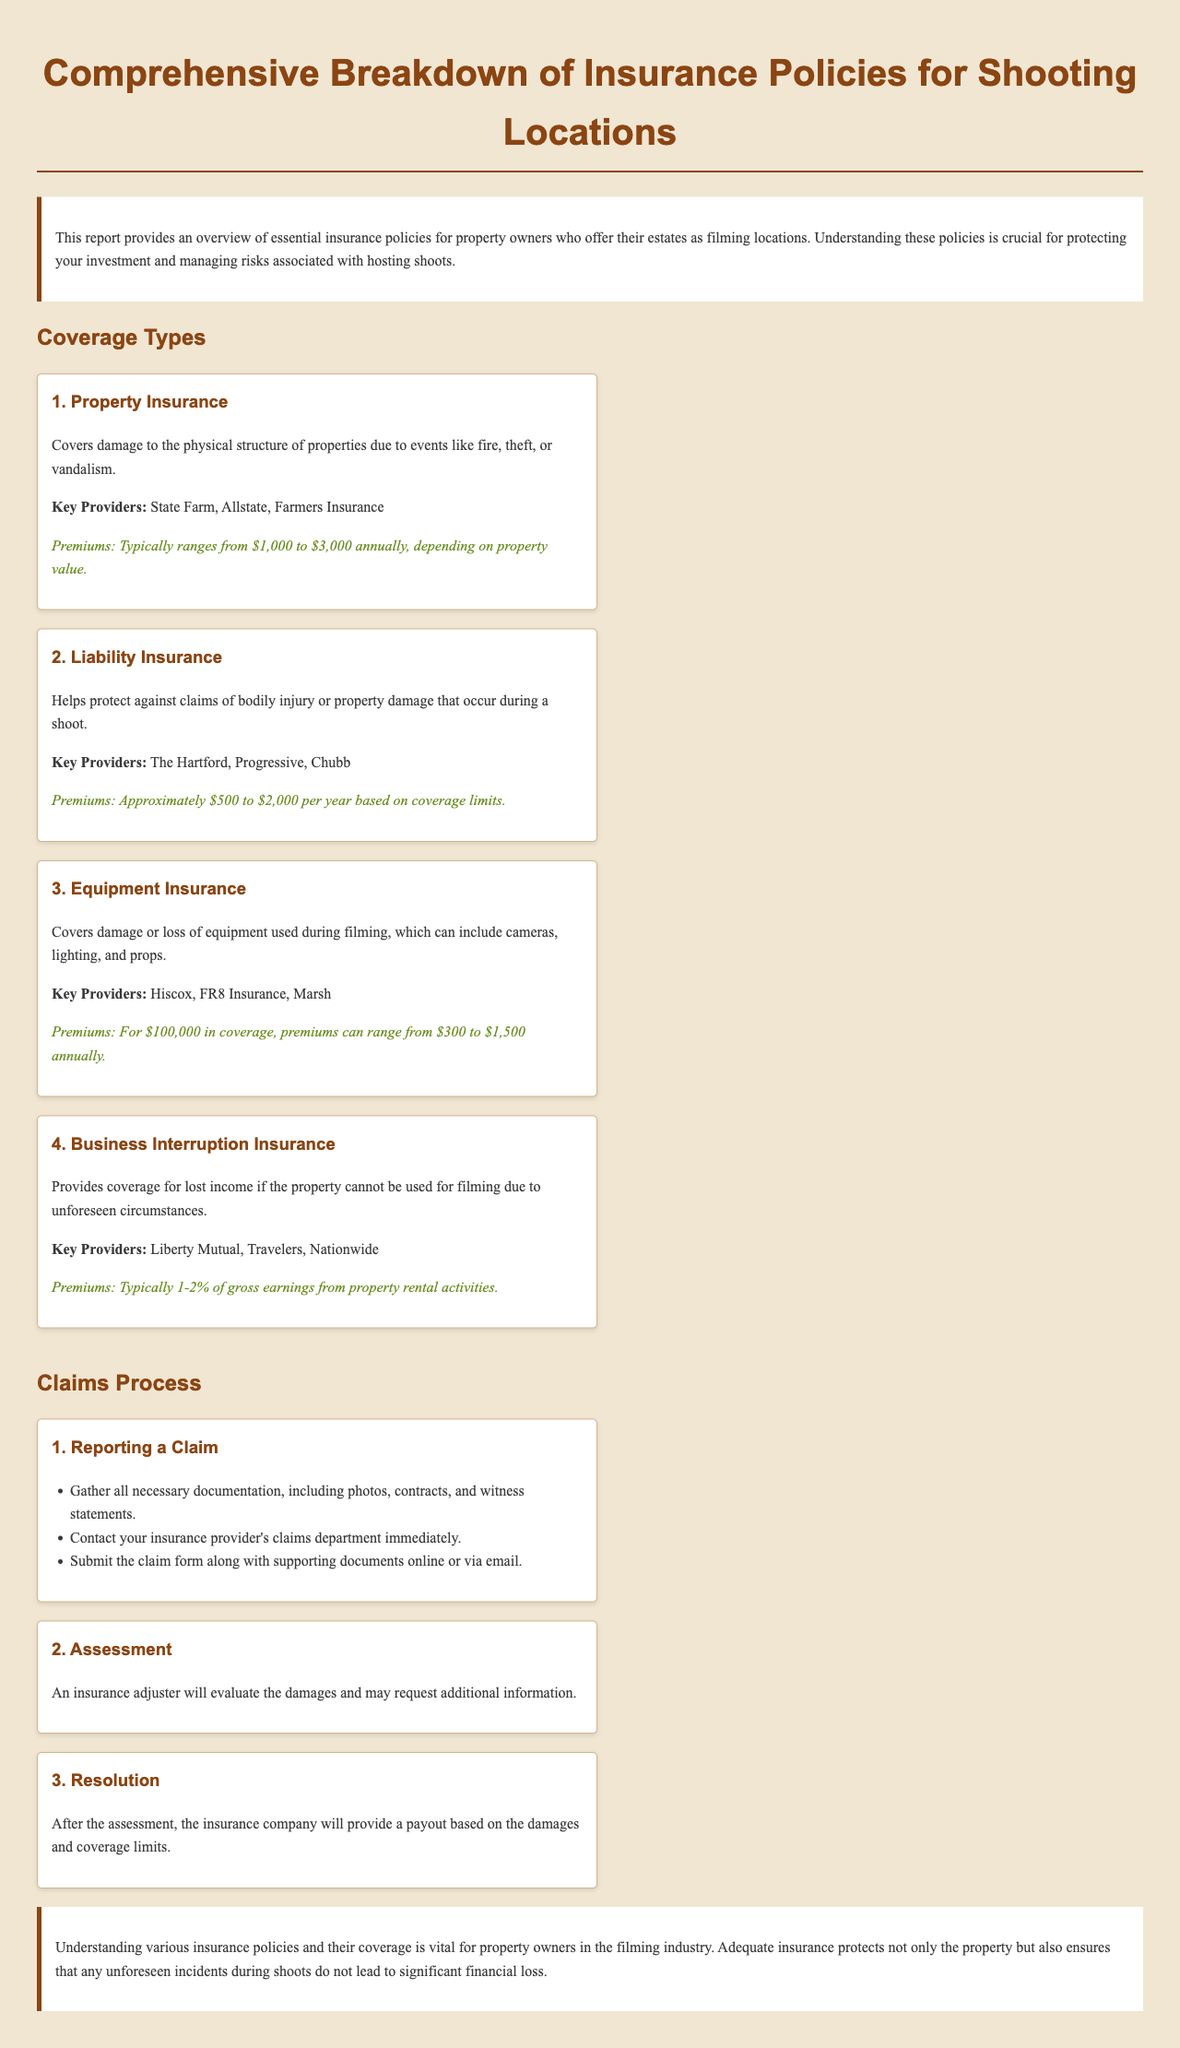What is the title of the report? The title is prominently displayed at the beginning of the document.
Answer: Comprehensive Breakdown of Insurance Policies for Shooting Locations What does Property Insurance cover? The document states the specific risks covered by Property Insurance.
Answer: Damage to the physical structure of properties Who are the key providers for Liability Insurance? The document lists specific companies that offer this type of insurance.
Answer: The Hartford, Progressive, Chubb What is the premium range for Equipment Insurance? The document provides specific numeric values for Equipment Insurance premiums.
Answer: $300 to $1,500 annually What step comes after Reporting a Claim? The process outlined in the document details the sequence of steps in the claims process.
Answer: Assessment What type of insurance is typically 1-2% of gross earnings? The document states the specific type of insurance and its corresponding percentage.
Answer: Business Interruption Insurance How many coverage types are listed in the document? The document organizes different types of insurance coverage in a structured way.
Answer: Four What is the expected annual premium for Property Insurance based on property value? The document provides a numeric range for premiums related to Property Insurance.
Answer: $1,000 to $3,000 annually What is the purpose of Business Interruption Insurance? The document explains the purpose of this specific type of insurance clearly.
Answer: Covers lost income if the property cannot be used for filming 